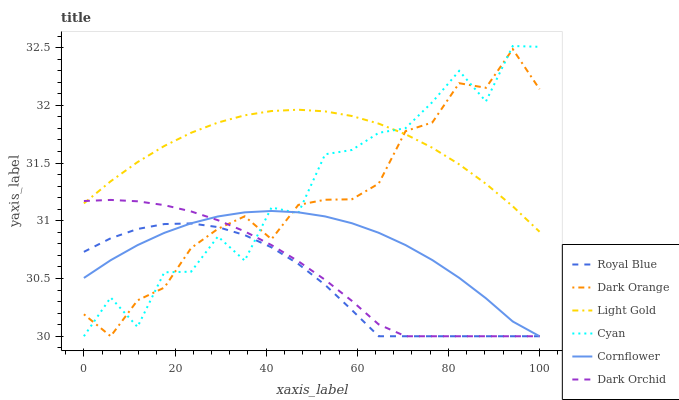Does Royal Blue have the minimum area under the curve?
Answer yes or no. Yes. Does Light Gold have the maximum area under the curve?
Answer yes or no. Yes. Does Dark Orange have the minimum area under the curve?
Answer yes or no. No. Does Dark Orange have the maximum area under the curve?
Answer yes or no. No. Is Light Gold the smoothest?
Answer yes or no. Yes. Is Cyan the roughest?
Answer yes or no. Yes. Is Dark Orange the smoothest?
Answer yes or no. No. Is Dark Orange the roughest?
Answer yes or no. No. Does Cornflower have the lowest value?
Answer yes or no. Yes. Does Light Gold have the lowest value?
Answer yes or no. No. Does Cyan have the highest value?
Answer yes or no. Yes. Does Dark Orange have the highest value?
Answer yes or no. No. Is Royal Blue less than Light Gold?
Answer yes or no. Yes. Is Light Gold greater than Cornflower?
Answer yes or no. Yes. Does Cyan intersect Dark Orange?
Answer yes or no. Yes. Is Cyan less than Dark Orange?
Answer yes or no. No. Is Cyan greater than Dark Orange?
Answer yes or no. No. Does Royal Blue intersect Light Gold?
Answer yes or no. No. 